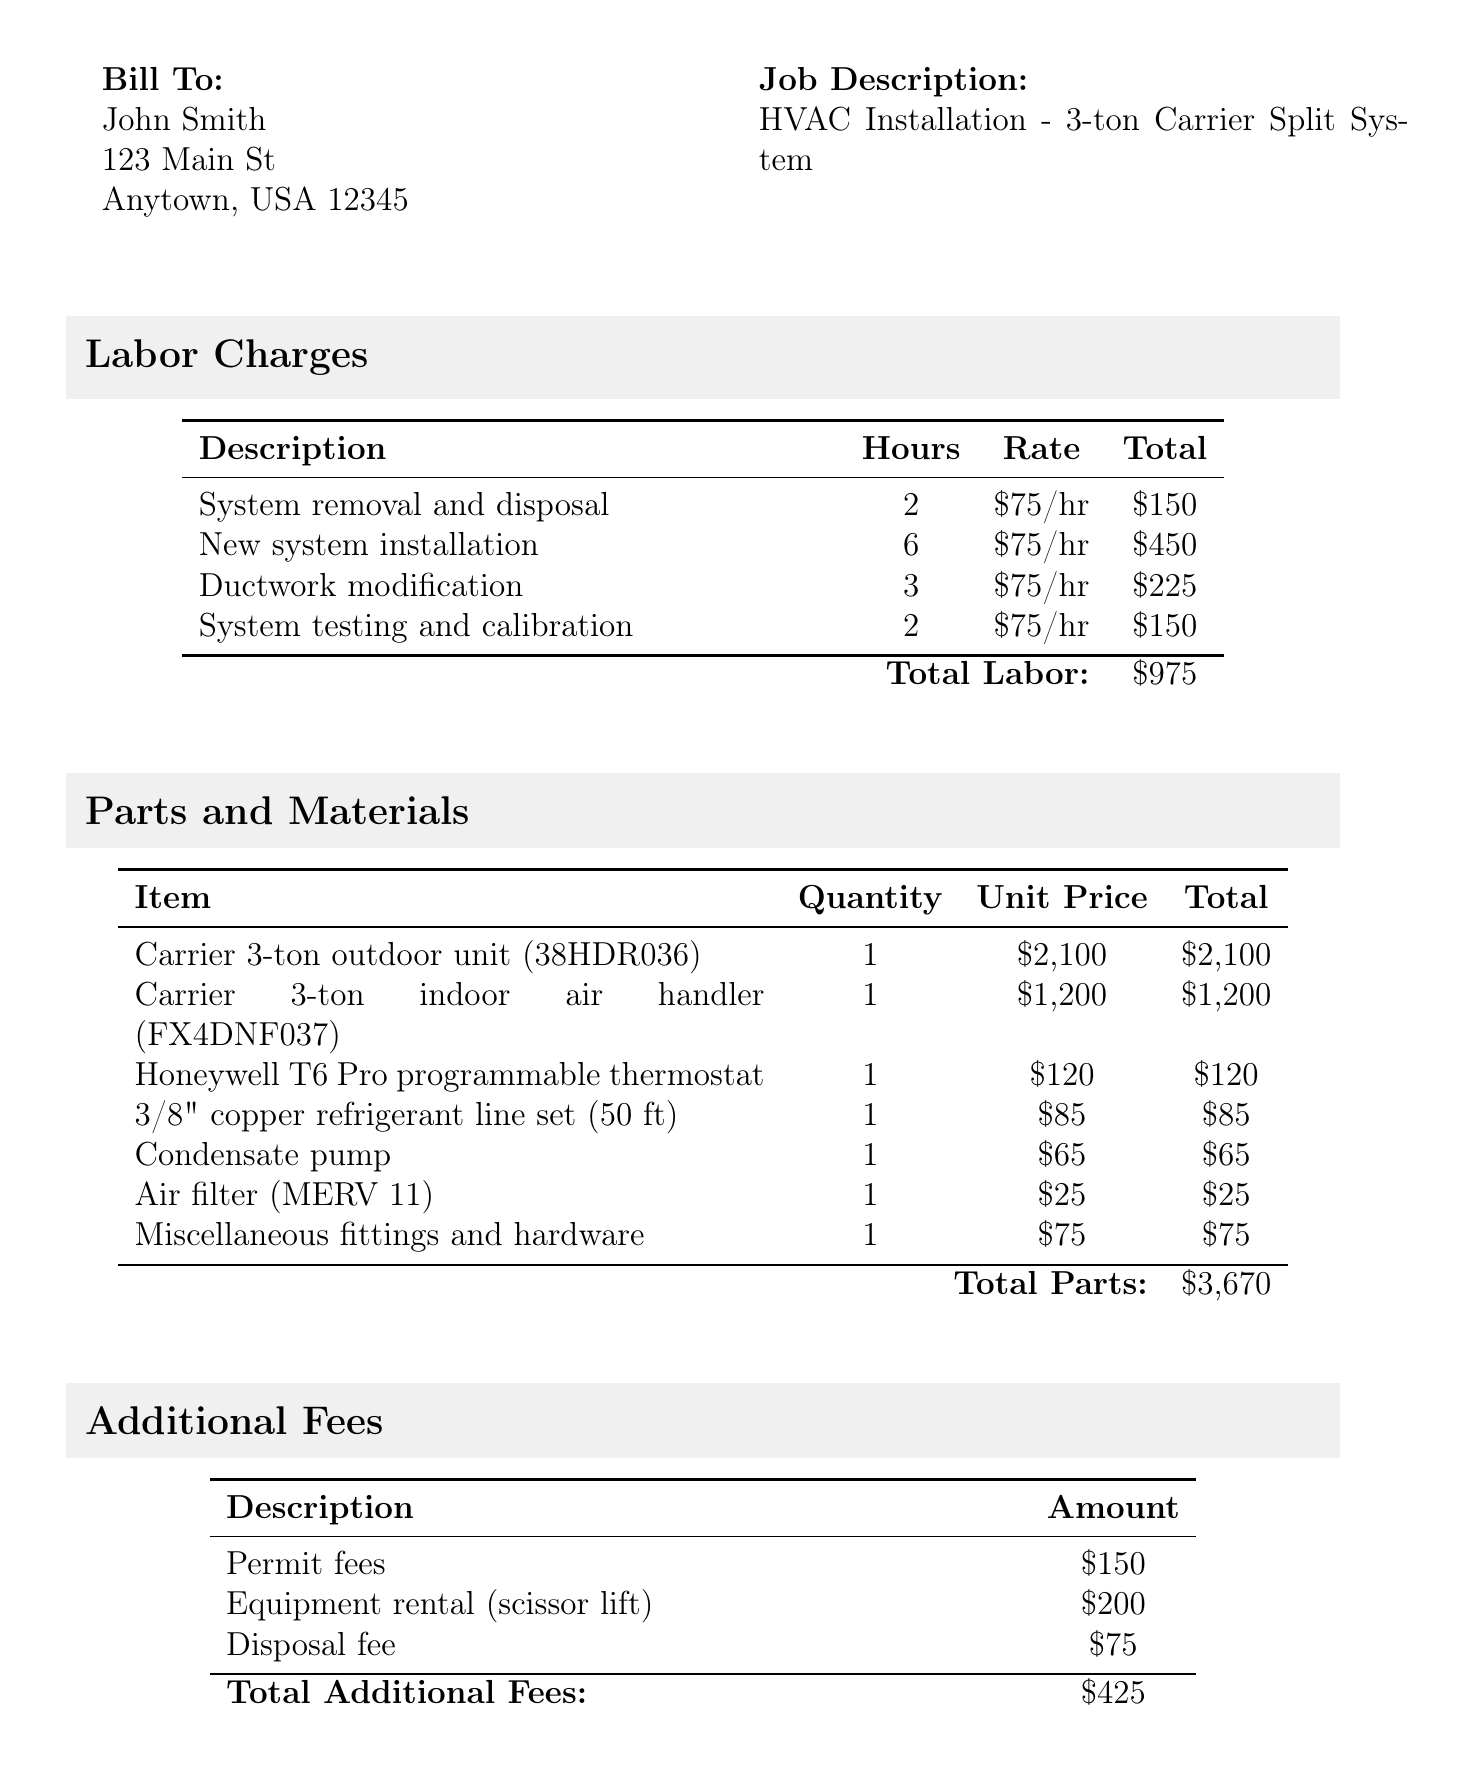What is the invoice number? The invoice number is listed at the top of the document under the invoice header.
Answer: INV-HVAC-2023-056 Who is the customer? The customer's name is provided in the billing section of the document.
Answer: John Smith What is the date of the invoice? The date appears alongside the invoice number at the top of the document.
Answer: 2023-05-15 How many hours were billed for new system installation? The number of hours for new system installation is specified in the labor charges section.
Answer: 6 What is the total cost of parts used? The total cost of parts is calculated and displayed at the end of the parts and materials section.
Answer: $3,670 What additional fee is listed for equipment rental? The document lists various additional fees, including equipment rental, specifying the amount charged.
Answer: $200 What is the subtotal before tax? The subtotal is calculated from the total labor and parts, as shown in the final section of the document.
Answer: $5,070 What is included in the notes at the bottom of the invoice? The notes section outlines additional details regarding warranties and completion of work.
Answer: 1-year labor warranty included How much is the tax on the total? The tax amount is explicitly stated in the final calculation section of the document.
Answer: $405.60 What is the total amount due? The total due is the final amount calculated and presented prominently at the bottom of the document.
Answer: $5,475.60 